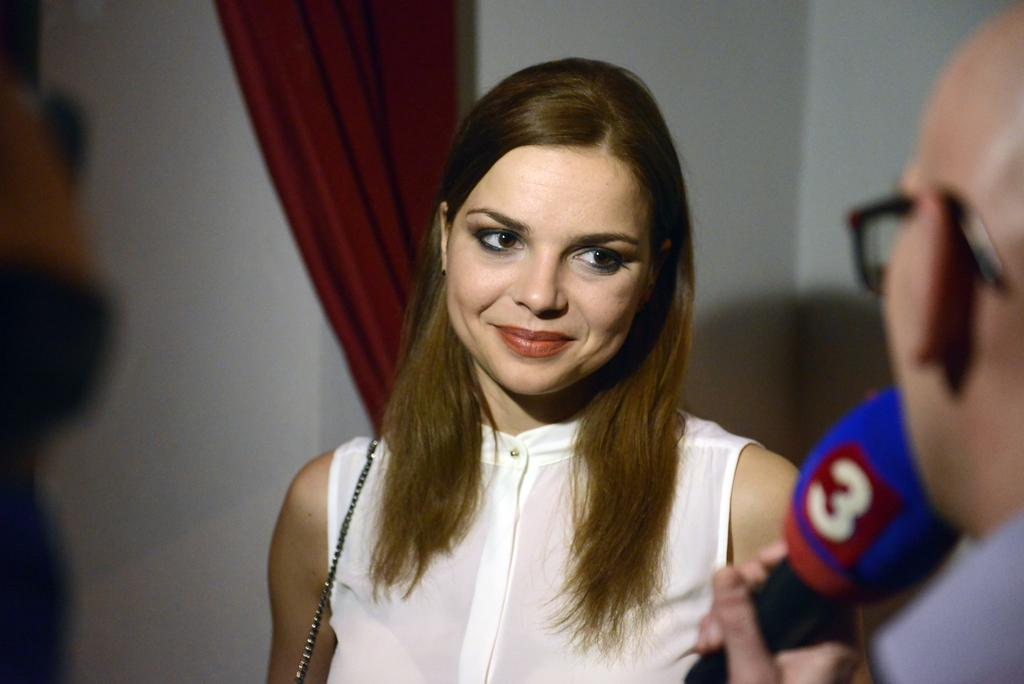Who is present in the image? There is a woman and a person in the image. What is the woman wearing? The woman is wearing a white dress. What is the person holding? The person is holding a microphone. What can be seen behind the woman and the person? There is a red curtain in the image. What color are the walls in the image? The walls in the image are white. What type of fang can be seen in the woman's mouth in the image? There is no fang visible in the woman's mouth in the image. How does the behavior of the person holding the microphone change throughout the image? The behavior of the person holding the microphone cannot be determined from the image, as it only shows a single moment in time. 